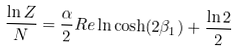<formula> <loc_0><loc_0><loc_500><loc_500>\frac { \ln Z } { N } = \frac { \alpha } { 2 } R e \ln \cosh ( 2 \beta _ { 1 } ) + \frac { \ln 2 } { 2 }</formula> 